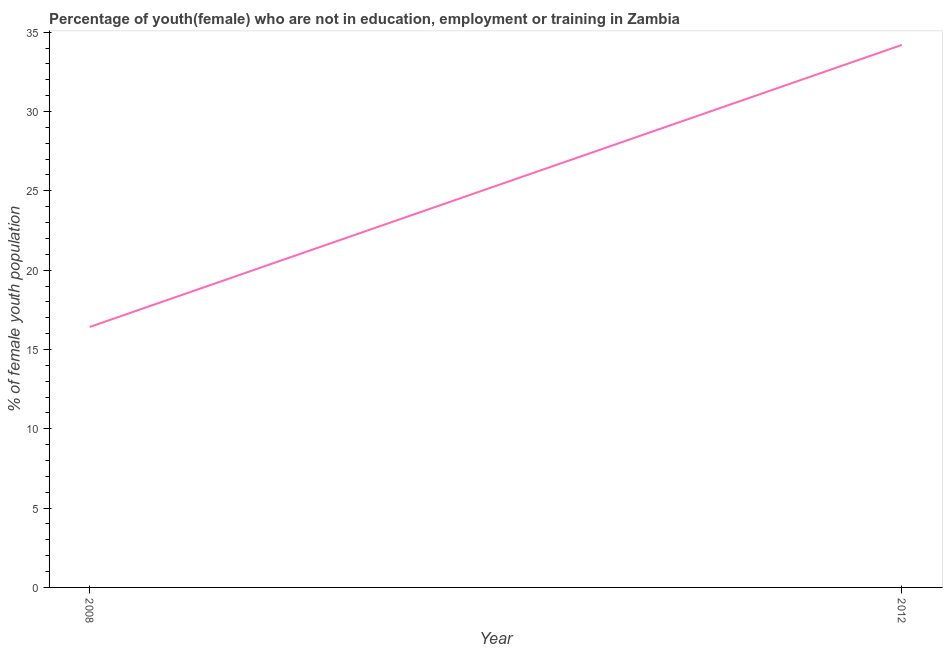What is the unemployed female youth population in 2012?
Your response must be concise. 34.2. Across all years, what is the maximum unemployed female youth population?
Your answer should be very brief. 34.2. Across all years, what is the minimum unemployed female youth population?
Offer a very short reply. 16.42. In which year was the unemployed female youth population maximum?
Your answer should be very brief. 2012. In which year was the unemployed female youth population minimum?
Keep it short and to the point. 2008. What is the sum of the unemployed female youth population?
Your response must be concise. 50.62. What is the difference between the unemployed female youth population in 2008 and 2012?
Keep it short and to the point. -17.78. What is the average unemployed female youth population per year?
Offer a terse response. 25.31. What is the median unemployed female youth population?
Keep it short and to the point. 25.31. In how many years, is the unemployed female youth population greater than 32 %?
Provide a succinct answer. 1. Do a majority of the years between 2012 and 2008 (inclusive) have unemployed female youth population greater than 34 %?
Your response must be concise. No. What is the ratio of the unemployed female youth population in 2008 to that in 2012?
Give a very brief answer. 0.48. Is the unemployed female youth population in 2008 less than that in 2012?
Provide a succinct answer. Yes. In how many years, is the unemployed female youth population greater than the average unemployed female youth population taken over all years?
Give a very brief answer. 1. How many lines are there?
Your answer should be very brief. 1. What is the difference between two consecutive major ticks on the Y-axis?
Offer a terse response. 5. Are the values on the major ticks of Y-axis written in scientific E-notation?
Offer a terse response. No. Does the graph contain any zero values?
Keep it short and to the point. No. Does the graph contain grids?
Your response must be concise. No. What is the title of the graph?
Your response must be concise. Percentage of youth(female) who are not in education, employment or training in Zambia. What is the label or title of the X-axis?
Offer a terse response. Year. What is the label or title of the Y-axis?
Your answer should be very brief. % of female youth population. What is the % of female youth population in 2008?
Provide a short and direct response. 16.42. What is the % of female youth population of 2012?
Keep it short and to the point. 34.2. What is the difference between the % of female youth population in 2008 and 2012?
Ensure brevity in your answer.  -17.78. What is the ratio of the % of female youth population in 2008 to that in 2012?
Your answer should be very brief. 0.48. 